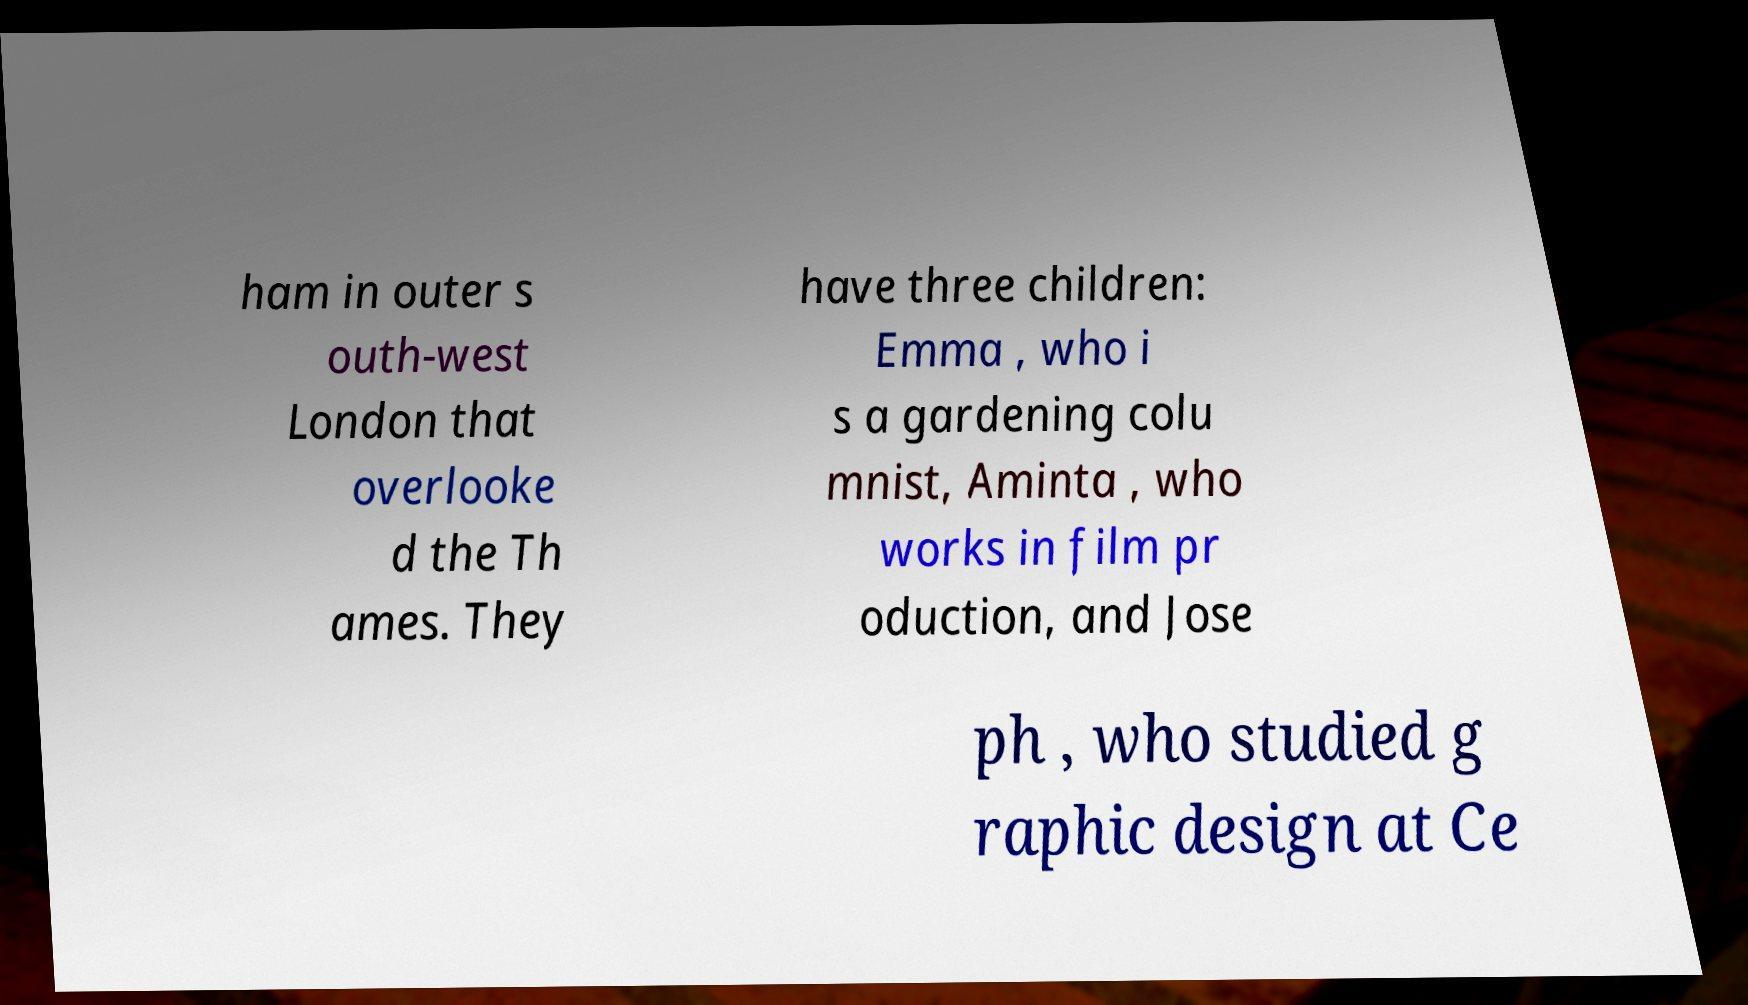Please identify and transcribe the text found in this image. ham in outer s outh-west London that overlooke d the Th ames. They have three children: Emma , who i s a gardening colu mnist, Aminta , who works in film pr oduction, and Jose ph , who studied g raphic design at Ce 